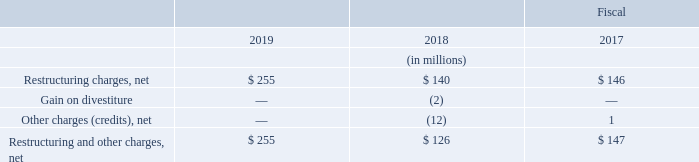3. Restructuring and Other Charges, Net
Net restructuring and other charges consisted of the following:
What was the amount of Restructuring and Other Charges, Net in 2019?
Answer scale should be: million. $ 255. For which years was the amount of Restructuring and Other Charges, Net calculated in? 2019, 2018, 2017. What are the components considered under Restructuring and Other Charges, Net? Restructuring charges, net, gain on divestiture, other charges (credits), net. In which year was Restructuring charges, net the lowest? 140<146<255
Answer: 2018. What was the change in Restructuring charges, net in 2019 from 2018?
Answer scale should be: million. 255-140
Answer: 115. What was the percentage change in Restructuring charges, net in 2019 from 2018?
Answer scale should be: percent. (255-140)/140
Answer: 82.14. 